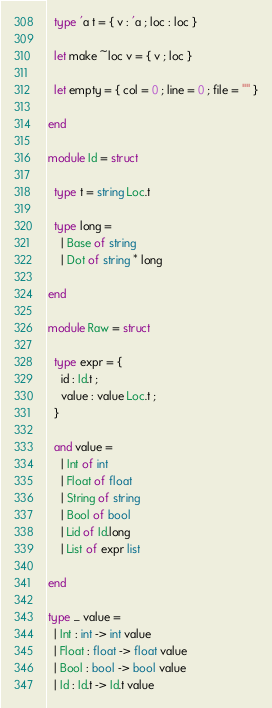<code> <loc_0><loc_0><loc_500><loc_500><_OCaml_>  type 'a t = { v : 'a ; loc : loc }

  let make ~loc v = { v ; loc }

  let empty = { col = 0 ; line = 0 ; file = "" }

end

module Id = struct

  type t = string Loc.t

  type long =
    | Base of string
    | Dot of string * long

end

module Raw = struct

  type expr = {
    id : Id.t ;
    value : value Loc.t ;
  }

  and value =
    | Int of int
    | Float of float
    | String of string
    | Bool of bool
    | Lid of Id.long
    | List of expr list

end

type _ value =
  | Int : int -> int value
  | Float : float -> float value
  | Bool : bool -> bool value
  | Id : Id.t -> Id.t value
</code> 